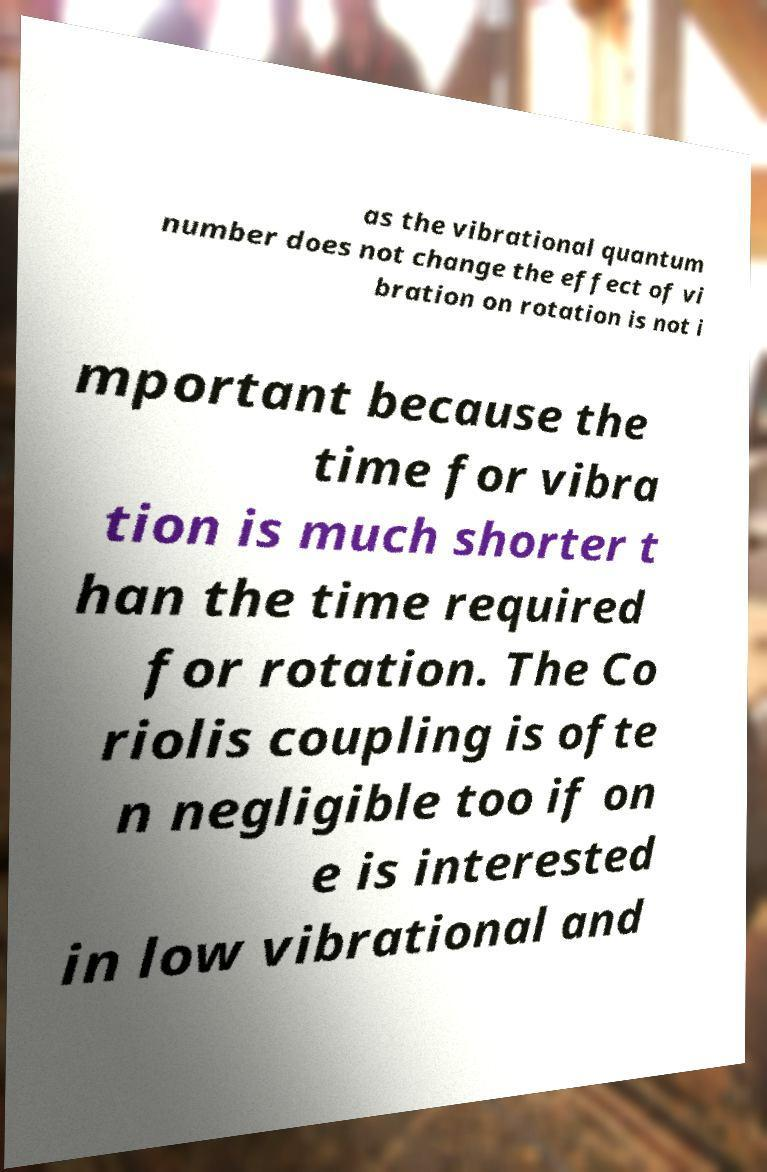What messages or text are displayed in this image? I need them in a readable, typed format. as the vibrational quantum number does not change the effect of vi bration on rotation is not i mportant because the time for vibra tion is much shorter t han the time required for rotation. The Co riolis coupling is ofte n negligible too if on e is interested in low vibrational and 